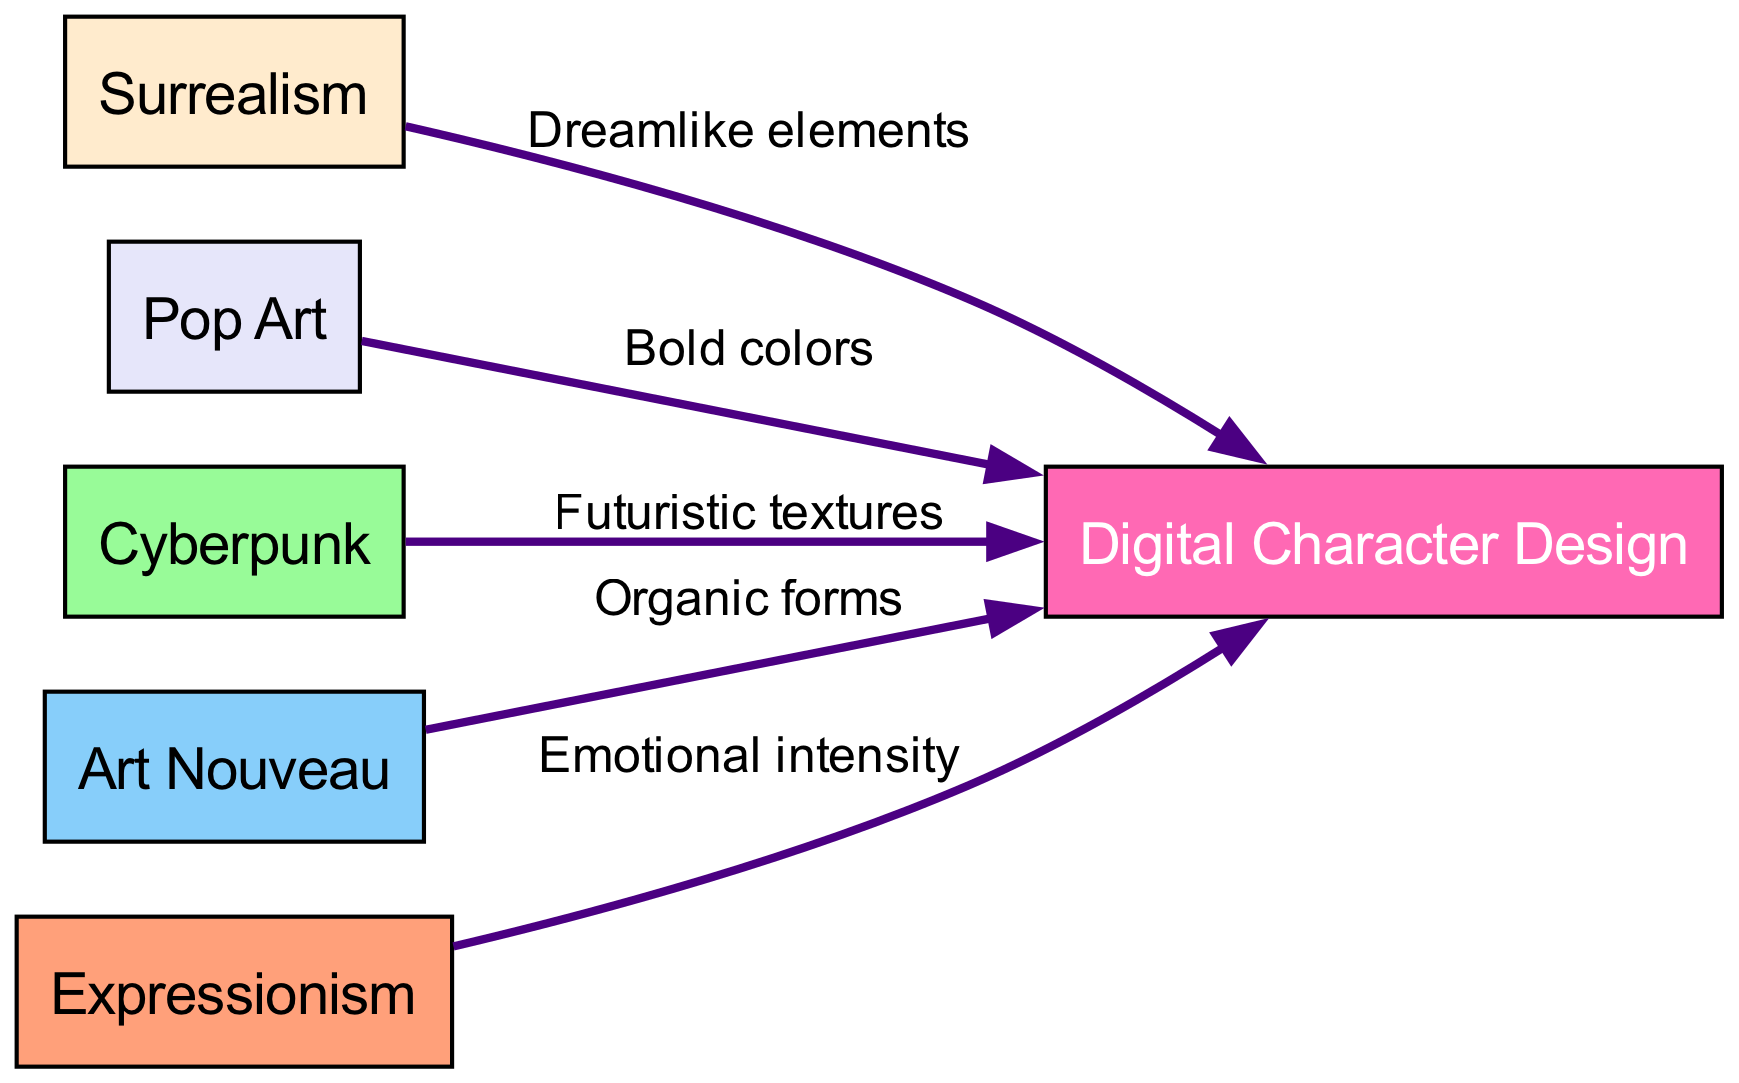What is the total number of nodes in the diagram? The nodes consist of "Digital Character Design," "Surrealism," "Pop Art," "Cyberpunk," "Art Nouveau," and "Expressionism." Counting these gives a total of six nodes.
Answer: 6 Which artistic movement is connected to digital character design by "Bold colors"? The edge labeled "Bold colors" connects "Pop Art" to "Digital Character Design." Therefore, "Pop Art" is the answer.
Answer: Pop Art What type of elements does Surrealism contribute to Digital Character Design? The edge from "Surrealism" to "Digital Character Design" is labeled "Dreamlike elements," indicating the specific contribution of this artistic movement.
Answer: Dreamlike elements How many edges are connected to the Digital Character Design node? The edges connected to "Digital Character Design" are from "Surrealism," "Pop Art," "Cyberpunk," "Art Nouveau," and "Expressionism," totaling to five edges.
Answer: 5 Which artistic movement emphasizes "Futuristic textures"? The label "Futuristic textures" is associated with the edge from "Cyberpunk" to "Digital Character Design." Thus, "Cyberpunk" is the correct artistic movement.
Answer: Cyberpunk What relationship do Expressionism and Digital Character Design share? The edge from "Expressionism" to "Digital Character Design" indicates a contribution of "Emotional intensity," describing the specific influence of Expressionism.
Answer: Emotional intensity Which node is central to the diagram? The node "Digital Character Design" is central, as all other artistic movements connect to it, demonstrating its importance in the diagram.
Answer: Digital Character Design Which artistic movement has the least number of connections? Each artistic movement is connected to the central node "Digital Character Design," and since all have only one outgoing edge, they all share the same number of connections. Thus, there is no singular least connected artistic movement.
Answer: None 